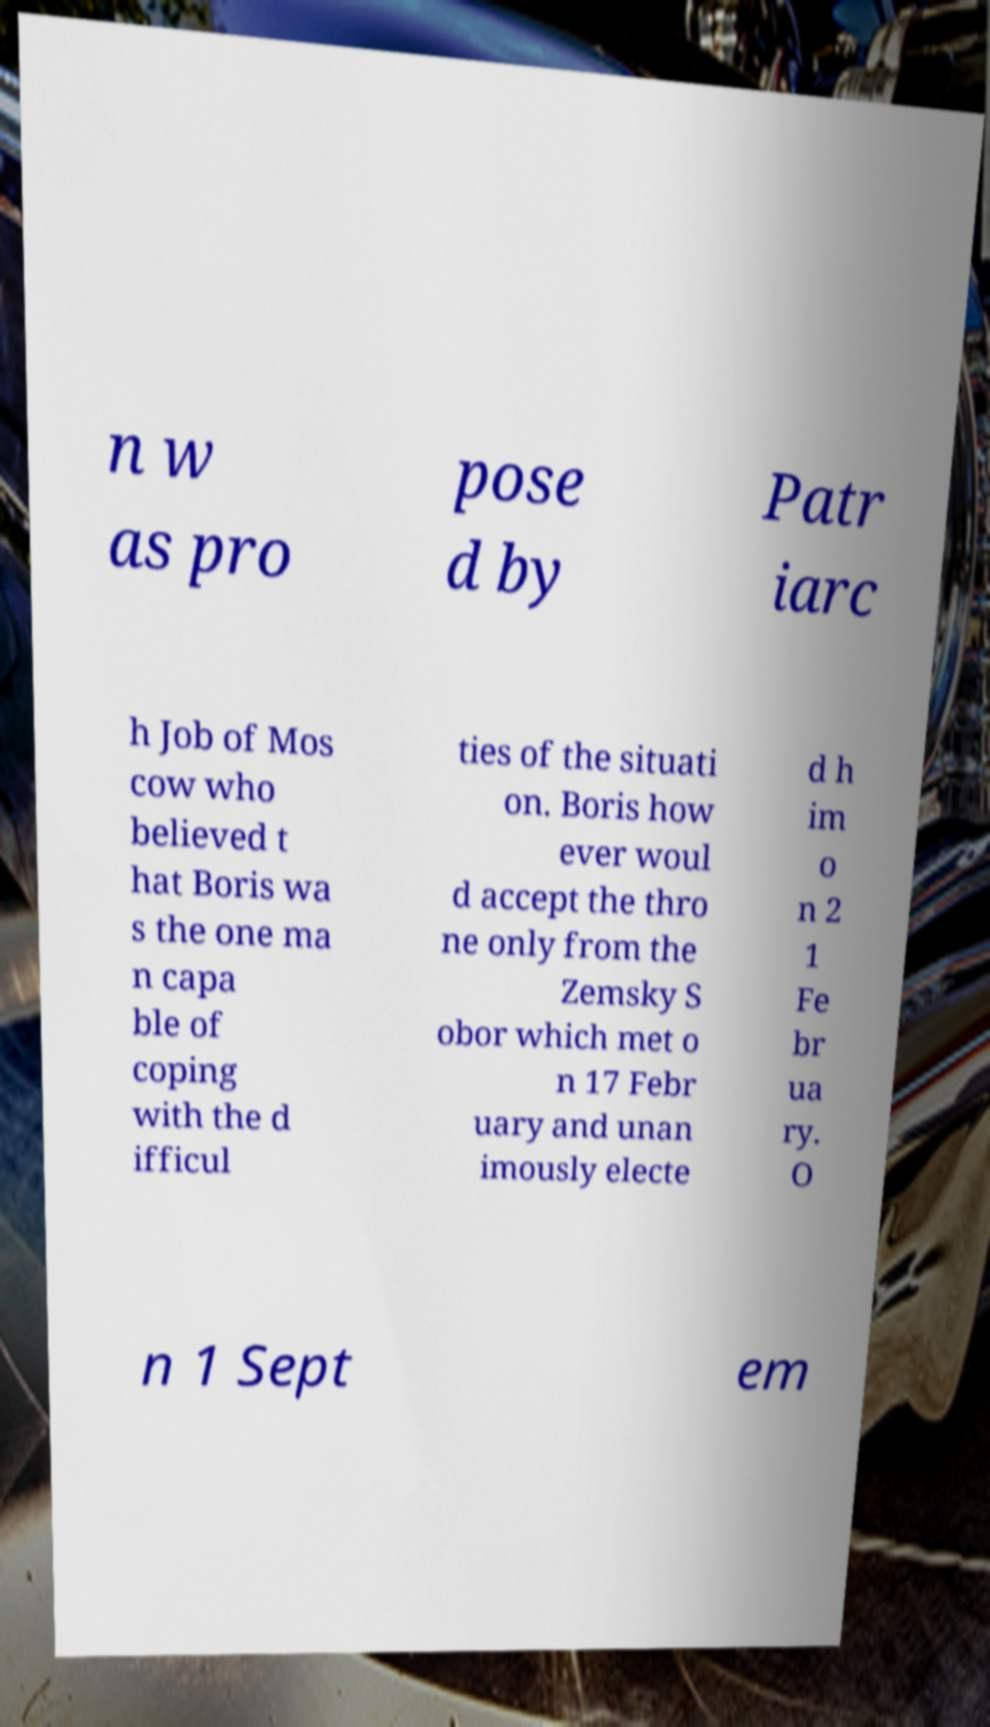What messages or text are displayed in this image? I need them in a readable, typed format. n w as pro pose d by Patr iarc h Job of Mos cow who believed t hat Boris wa s the one ma n capa ble of coping with the d ifficul ties of the situati on. Boris how ever woul d accept the thro ne only from the Zemsky S obor which met o n 17 Febr uary and unan imously electe d h im o n 2 1 Fe br ua ry. O n 1 Sept em 